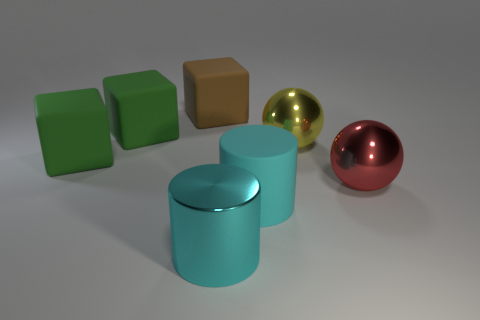Is the color of the matte cylinder the same as the shiny cylinder?
Ensure brevity in your answer.  Yes. How many things are big cylinders or things behind the large cyan shiny cylinder?
Your answer should be compact. 7. There is a metallic thing that is in front of the large red thing; is its shape the same as the large cyan matte thing in front of the yellow shiny ball?
Make the answer very short. Yes. What number of objects are big brown things or red matte things?
Make the answer very short. 1. Are there any things?
Ensure brevity in your answer.  Yes. Do the big cylinder on the left side of the big cyan rubber thing and the red sphere have the same material?
Ensure brevity in your answer.  Yes. Are there any other metal things of the same shape as the big yellow thing?
Give a very brief answer. Yes. Is the number of big metal balls to the left of the brown object the same as the number of large matte cylinders?
Your answer should be very brief. No. There is a big red object that is in front of the ball that is on the left side of the red sphere; what is its material?
Give a very brief answer. Metal. The red thing is what shape?
Offer a terse response. Sphere. 